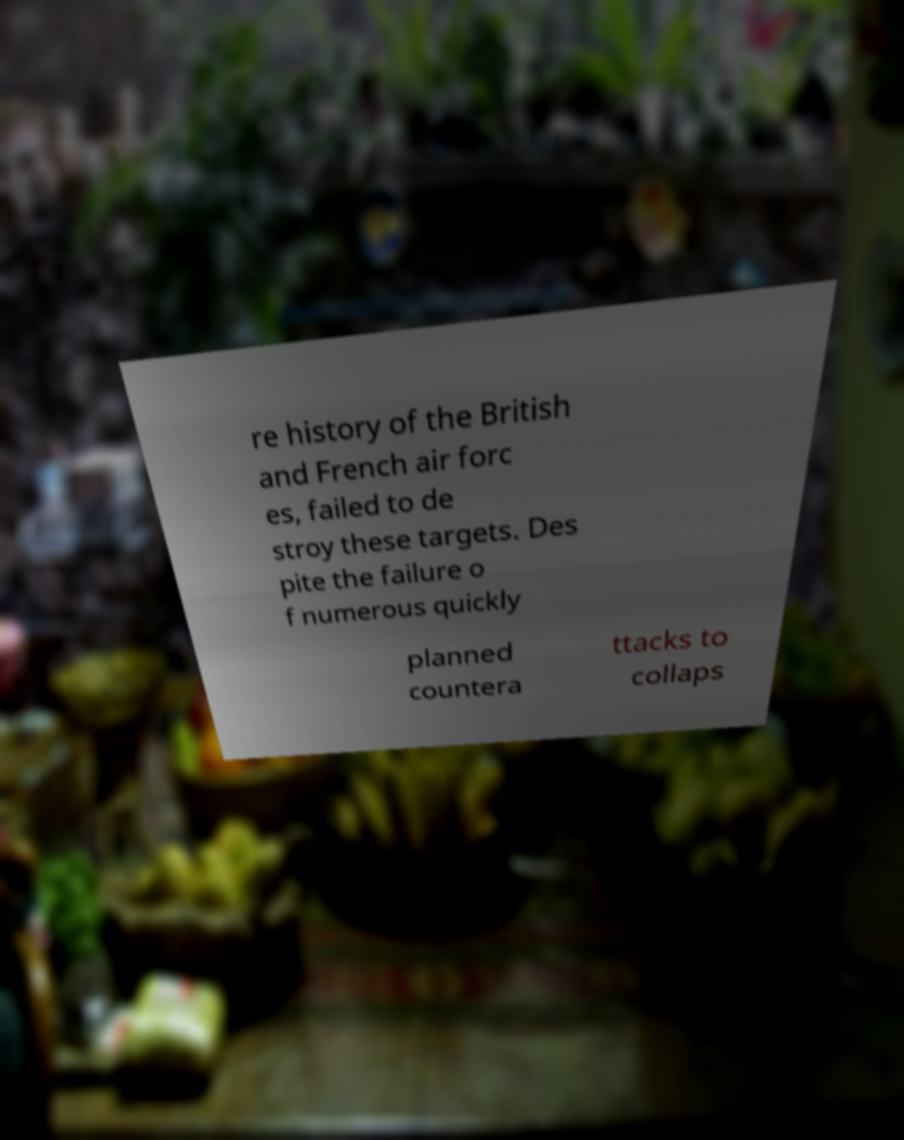For documentation purposes, I need the text within this image transcribed. Could you provide that? re history of the British and French air forc es, failed to de stroy these targets. Des pite the failure o f numerous quickly planned countera ttacks to collaps 